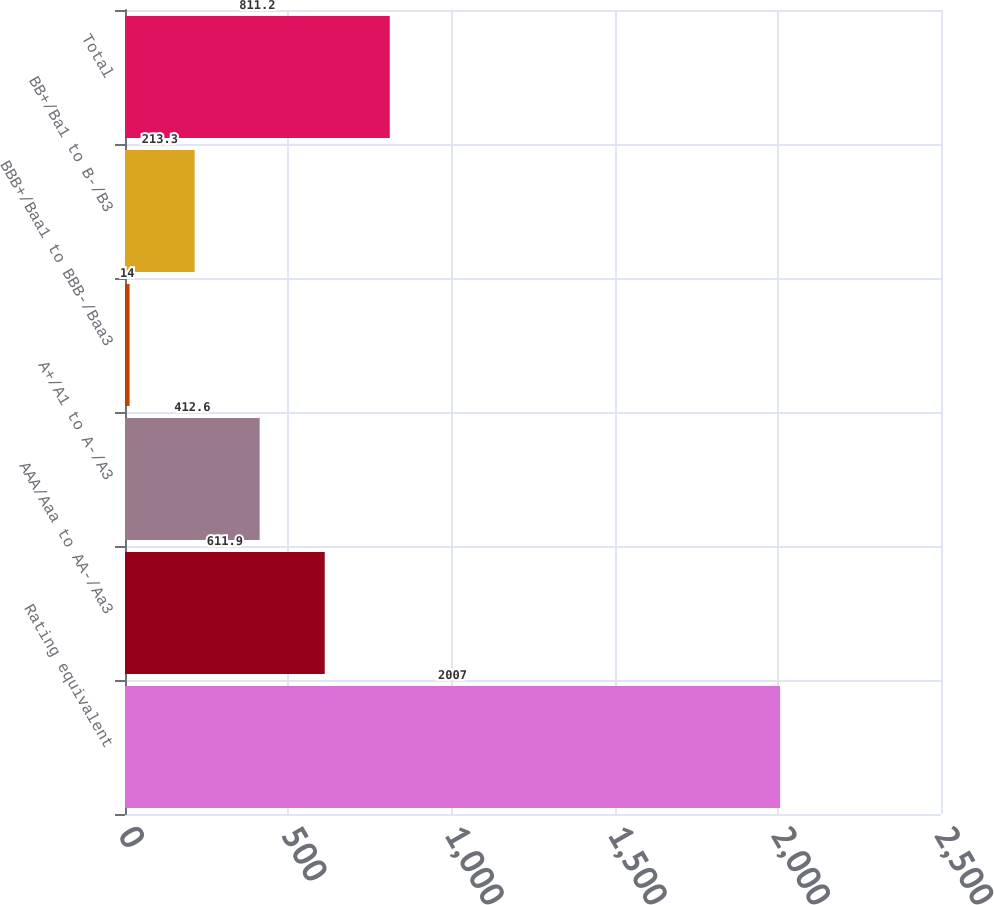Convert chart. <chart><loc_0><loc_0><loc_500><loc_500><bar_chart><fcel>Rating equivalent<fcel>AAA/Aaa to AA-/Aa3<fcel>A+/A1 to A-/A3<fcel>BBB+/Baa1 to BBB-/Baa3<fcel>BB+/Ba1 to B-/B3<fcel>Total<nl><fcel>2007<fcel>611.9<fcel>412.6<fcel>14<fcel>213.3<fcel>811.2<nl></chart> 